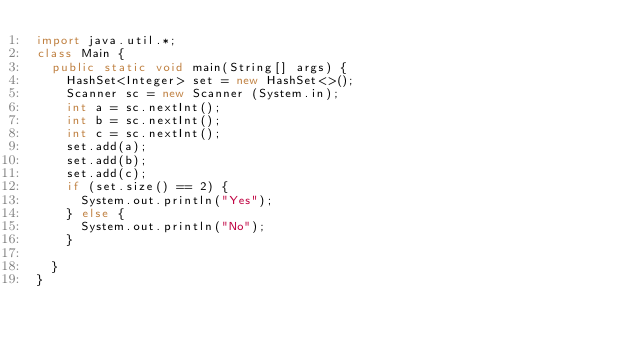Convert code to text. <code><loc_0><loc_0><loc_500><loc_500><_Java_>import java.util.*;
class Main {
  public static void main(String[] args) {
    HashSet<Integer> set = new HashSet<>();
    Scanner sc = new Scanner (System.in);
    int a = sc.nextInt(); 
    int b = sc.nextInt(); 
    int c = sc.nextInt();
    set.add(a); 
    set.add(b); 
    set.add(c);  
    if (set.size() == 2) {
      System.out.println("Yes");
    } else {
      System.out.println("No");
    }

  }
}</code> 